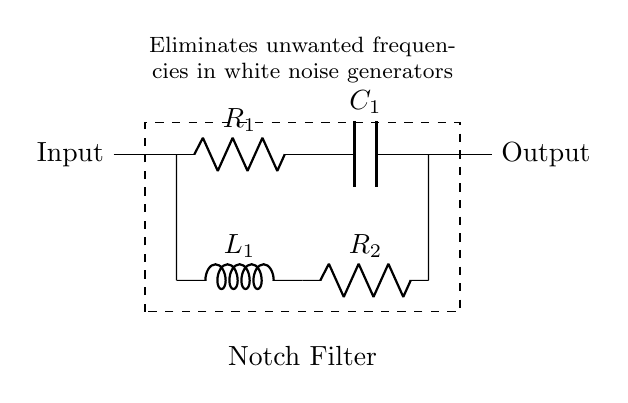What components are present in the circuit? The circuit includes a resistor, a capacitor, an inductor, and two additional resistors. These components are clearly labeled: R1, C1, L1, and R2.
Answer: Resistor, capacitor, inductor What is the purpose of this notch filter? The diagram indicates that the function of the notch filter is to eliminate unwanted frequencies in white noise generators, as stated in the accompanying text.
Answer: Eliminate unwanted frequencies What is the label for the input of the circuit? The circuit diagram labels the input terminal clearly, which is marked as "Input" on the left side of the diagram.
Answer: Input How many resistors are in the notch filter circuit? Upon inspecting the circuit, it is evident that there are two resistors present, labeled as R1 and R2.
Answer: Two What type of filter is depicted in this diagram? The circuit is specifically identified as a notch filter, which is indicated by the notation in the dashed rectangle surrounding the components.
Answer: Notch filter What is the label for the output of the circuit? The output terminal is labeled as "Output," which is placed on the right side of the diagram.
Answer: Output What is the total number of components (R, L, C) in the circuit? By counting the labeled components in the diagram, we find there are four total: two resistors (R1 and R2), one capacitor (C1), and one inductor (L1).
Answer: Four 